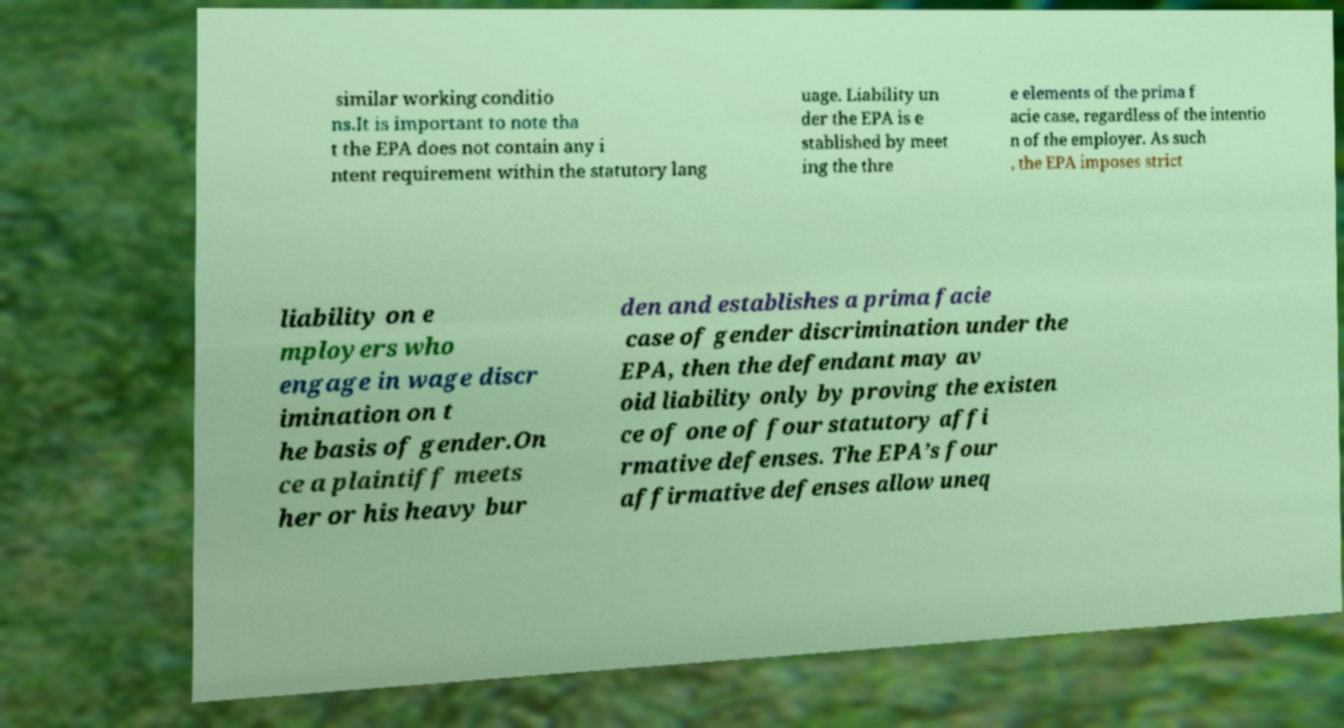There's text embedded in this image that I need extracted. Can you transcribe it verbatim? similar working conditio ns.It is important to note tha t the EPA does not contain any i ntent requirement within the statutory lang uage. Liability un der the EPA is e stablished by meet ing the thre e elements of the prima f acie case, regardless of the intentio n of the employer. As such , the EPA imposes strict liability on e mployers who engage in wage discr imination on t he basis of gender.On ce a plaintiff meets her or his heavy bur den and establishes a prima facie case of gender discrimination under the EPA, then the defendant may av oid liability only by proving the existen ce of one of four statutory affi rmative defenses. The EPA’s four affirmative defenses allow uneq 